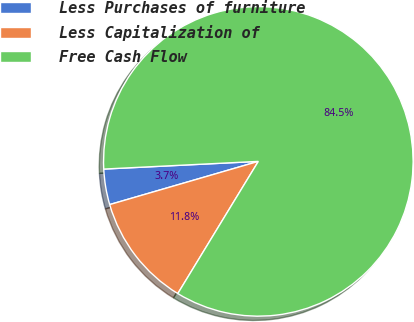Convert chart to OTSL. <chart><loc_0><loc_0><loc_500><loc_500><pie_chart><fcel>Less Purchases of furniture<fcel>Less Capitalization of<fcel>Free Cash Flow<nl><fcel>3.71%<fcel>11.79%<fcel>84.5%<nl></chart> 